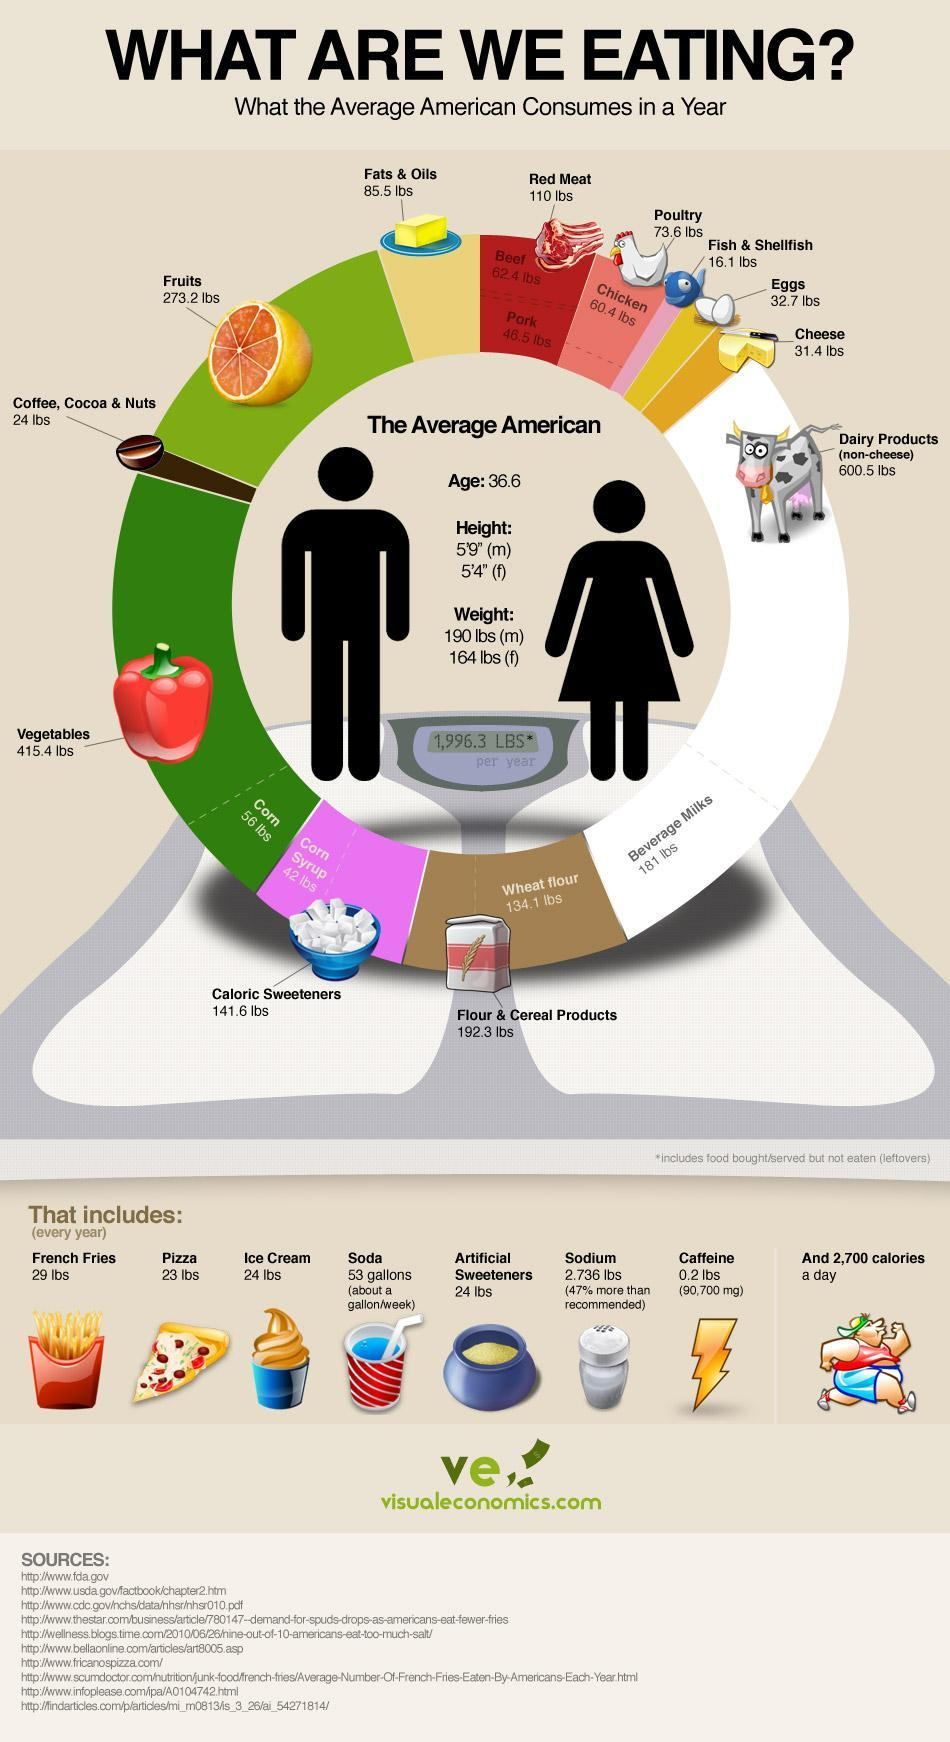How much lbs eggs and poultry does an average American consume in a year
Answer the question with a short phrase. 106.3 What is the height of an average American male 5'9" what is the weight of an average American female 164 lbs What is the weekly consumption of soda a gallon what is the colour of capsicum, red or green red what is the weight of an average American male 190 lbs What is the height of an average American female 5'4" Which are the 2 types of red meat Beef, Pork 